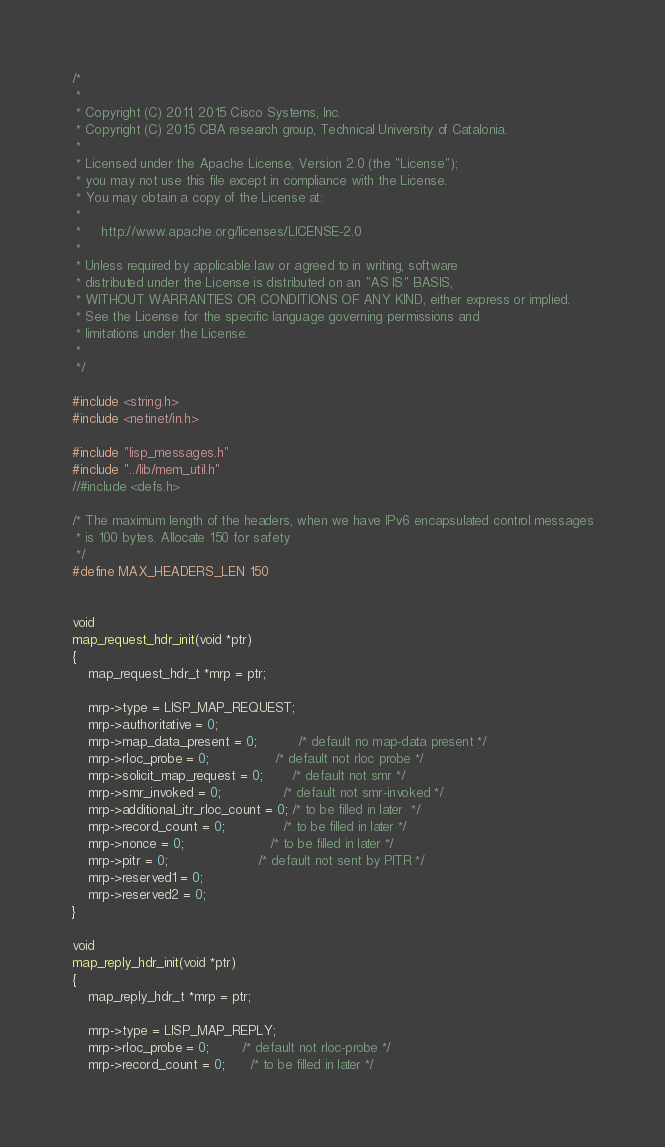Convert code to text. <code><loc_0><loc_0><loc_500><loc_500><_C_>/*
 *
 * Copyright (C) 2011, 2015 Cisco Systems, Inc.
 * Copyright (C) 2015 CBA research group, Technical University of Catalonia.
 *
 * Licensed under the Apache License, Version 2.0 (the "License");
 * you may not use this file except in compliance with the License.
 * You may obtain a copy of the License at:
 *
 *     http://www.apache.org/licenses/LICENSE-2.0
 *
 * Unless required by applicable law or agreed to in writing, software
 * distributed under the License is distributed on an "AS IS" BASIS,
 * WITHOUT WARRANTIES OR CONDITIONS OF ANY KIND, either express or implied.
 * See the License for the specific language governing permissions and
 * limitations under the License.
 *
 */

#include <string.h>
#include <netinet/in.h>

#include "lisp_messages.h"
#include "../lib/mem_util.h"
//#include <defs.h>

/* The maximum length of the headers, when we have IPv6 encapsulated control messages
 * is 100 bytes. Allocate 150 for safety
 */
#define MAX_HEADERS_LEN 150


void
map_request_hdr_init(void *ptr)
{
    map_request_hdr_t *mrp = ptr;

    mrp->type = LISP_MAP_REQUEST;
    mrp->authoritative = 0;
    mrp->map_data_present = 0;          /* default no map-data present */
    mrp->rloc_probe = 0;                /* default not rloc probe */
    mrp->solicit_map_request = 0;       /* default not smr */
    mrp->smr_invoked = 0;               /* default not smr-invoked */
    mrp->additional_itr_rloc_count = 0; /* to be filled in later  */
    mrp->record_count = 0;              /* to be filled in later */
    mrp->nonce = 0;                     /* to be filled in later */
    mrp->pitr = 0;                      /* default not sent by PITR */
    mrp->reserved1 = 0;
    mrp->reserved2 = 0;
}

void
map_reply_hdr_init(void *ptr)
{
    map_reply_hdr_t *mrp = ptr;

    mrp->type = LISP_MAP_REPLY;
    mrp->rloc_probe = 0;        /* default not rloc-probe */
    mrp->record_count = 0;      /* to be filled in later */</code> 